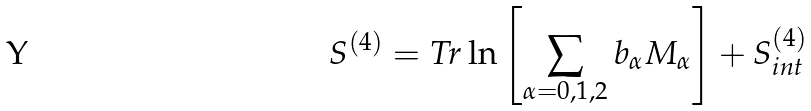<formula> <loc_0><loc_0><loc_500><loc_500>S ^ { ( 4 ) } = T r \ln \left [ \sum _ { \alpha = 0 , 1 , 2 } b _ { \alpha } M _ { \alpha } \right ] + S ^ { ( 4 ) } _ { i n t }</formula> 